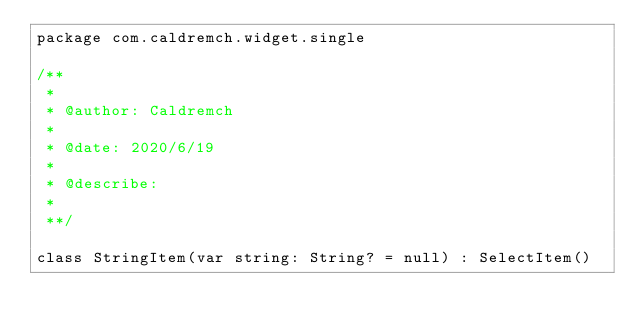Convert code to text. <code><loc_0><loc_0><loc_500><loc_500><_Kotlin_>package com.caldremch.widget.single

/**
 *
 * @author: Caldremch
 *
 * @date: 2020/6/19
 *
 * @describe:
 *
 **/

class StringItem(var string: String? = null) : SelectItem()</code> 